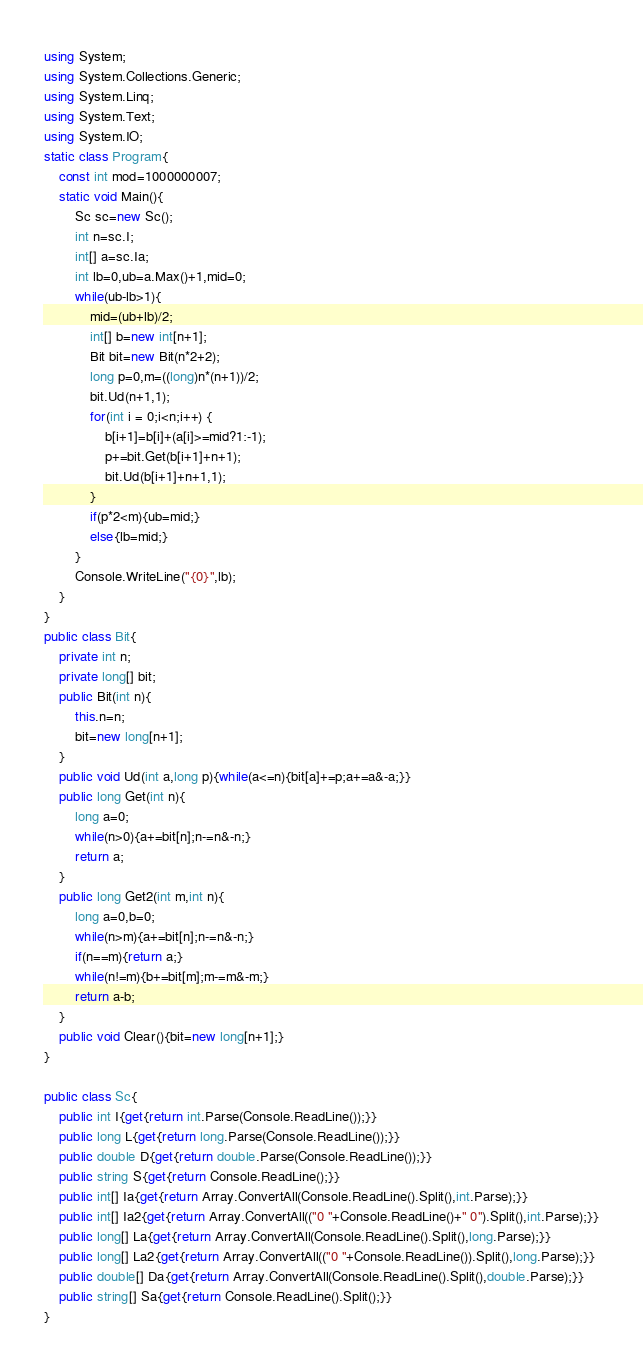Convert code to text. <code><loc_0><loc_0><loc_500><loc_500><_C#_>using System;
using System.Collections.Generic;
using System.Linq;
using System.Text;
using System.IO;
static class Program{
	const int mod=1000000007;
	static void Main(){
		Sc sc=new Sc();
		int n=sc.I;
		int[] a=sc.Ia;
		int lb=0,ub=a.Max()+1,mid=0;
		while(ub-lb>1){
			mid=(ub+lb)/2;
			int[] b=new int[n+1];
			Bit bit=new Bit(n*2+2);
			long p=0,m=((long)n*(n+1))/2;
			bit.Ud(n+1,1);
			for(int i = 0;i<n;i++) {
				b[i+1]=b[i]+(a[i]>=mid?1:-1);
				p+=bit.Get(b[i+1]+n+1);
				bit.Ud(b[i+1]+n+1,1);
			}
			if(p*2<m){ub=mid;}
			else{lb=mid;}
		}
		Console.WriteLine("{0}",lb);
	}
}
public class Bit{
	private int n;
	private long[] bit;
	public Bit(int n){
		this.n=n;
		bit=new long[n+1];
	}
	public void Ud(int a,long p){while(a<=n){bit[a]+=p;a+=a&-a;}}
	public long Get(int n){
		long a=0;
		while(n>0){a+=bit[n];n-=n&-n;}
		return a;
	}
	public long Get2(int m,int n){
		long a=0,b=0;
		while(n>m){a+=bit[n];n-=n&-n;}
		if(n==m){return a;}
		while(n!=m){b+=bit[m];m-=m&-m;}
		return a-b;
	}
	public void Clear(){bit=new long[n+1];}
}

public class Sc{
	public int I{get{return int.Parse(Console.ReadLine());}}
	public long L{get{return long.Parse(Console.ReadLine());}}
	public double D{get{return double.Parse(Console.ReadLine());}}
	public string S{get{return Console.ReadLine();}}
	public int[] Ia{get{return Array.ConvertAll(Console.ReadLine().Split(),int.Parse);}}
	public int[] Ia2{get{return Array.ConvertAll(("0 "+Console.ReadLine()+" 0").Split(),int.Parse);}}
	public long[] La{get{return Array.ConvertAll(Console.ReadLine().Split(),long.Parse);}}
	public long[] La2{get{return Array.ConvertAll(("0 "+Console.ReadLine()).Split(),long.Parse);}}
	public double[] Da{get{return Array.ConvertAll(Console.ReadLine().Split(),double.Parse);}}
	public string[] Sa{get{return Console.ReadLine().Split();}}
}</code> 